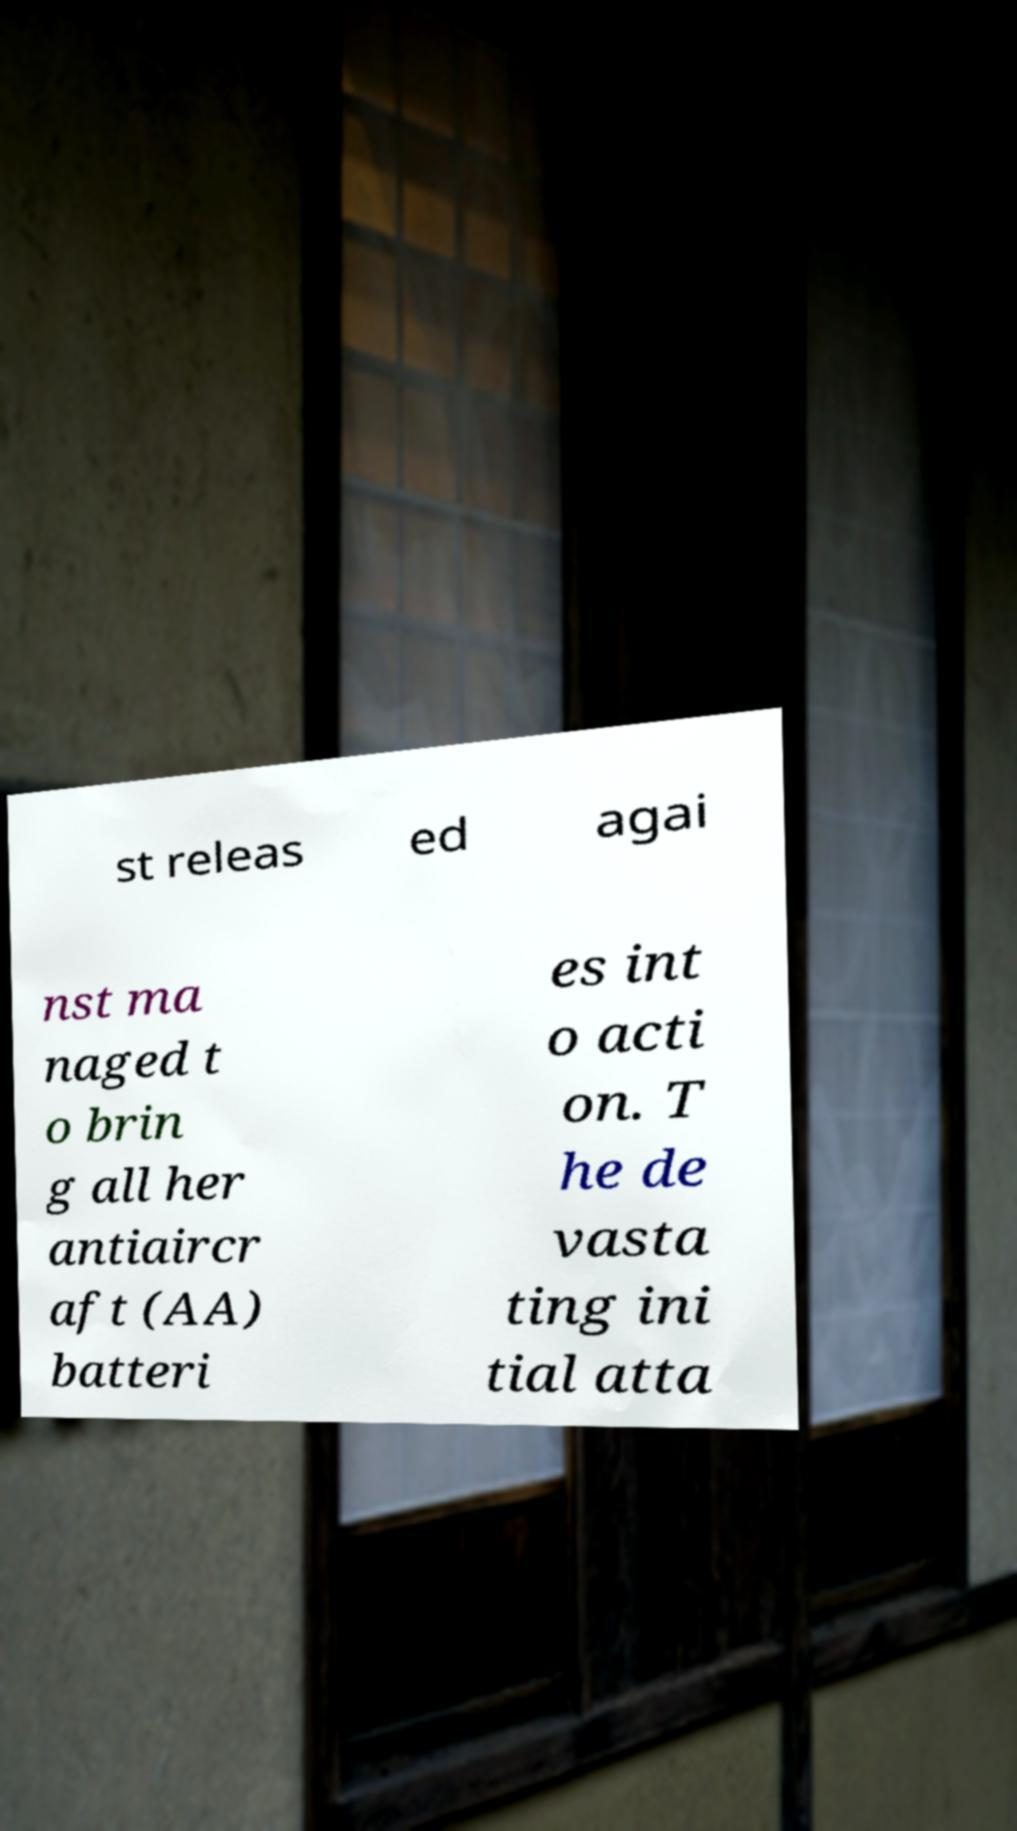What messages or text are displayed in this image? I need them in a readable, typed format. st releas ed agai nst ma naged t o brin g all her antiaircr aft (AA) batteri es int o acti on. T he de vasta ting ini tial atta 